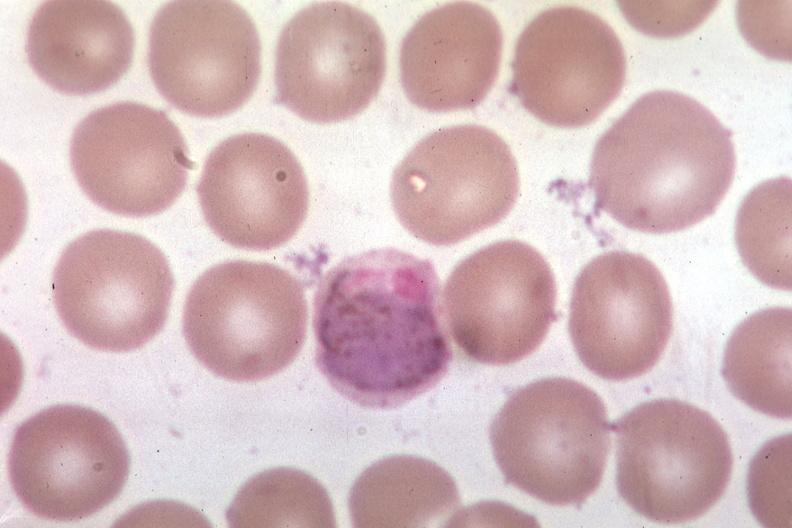what does this image show?
Answer the question using a single word or phrase. Oil wrights 